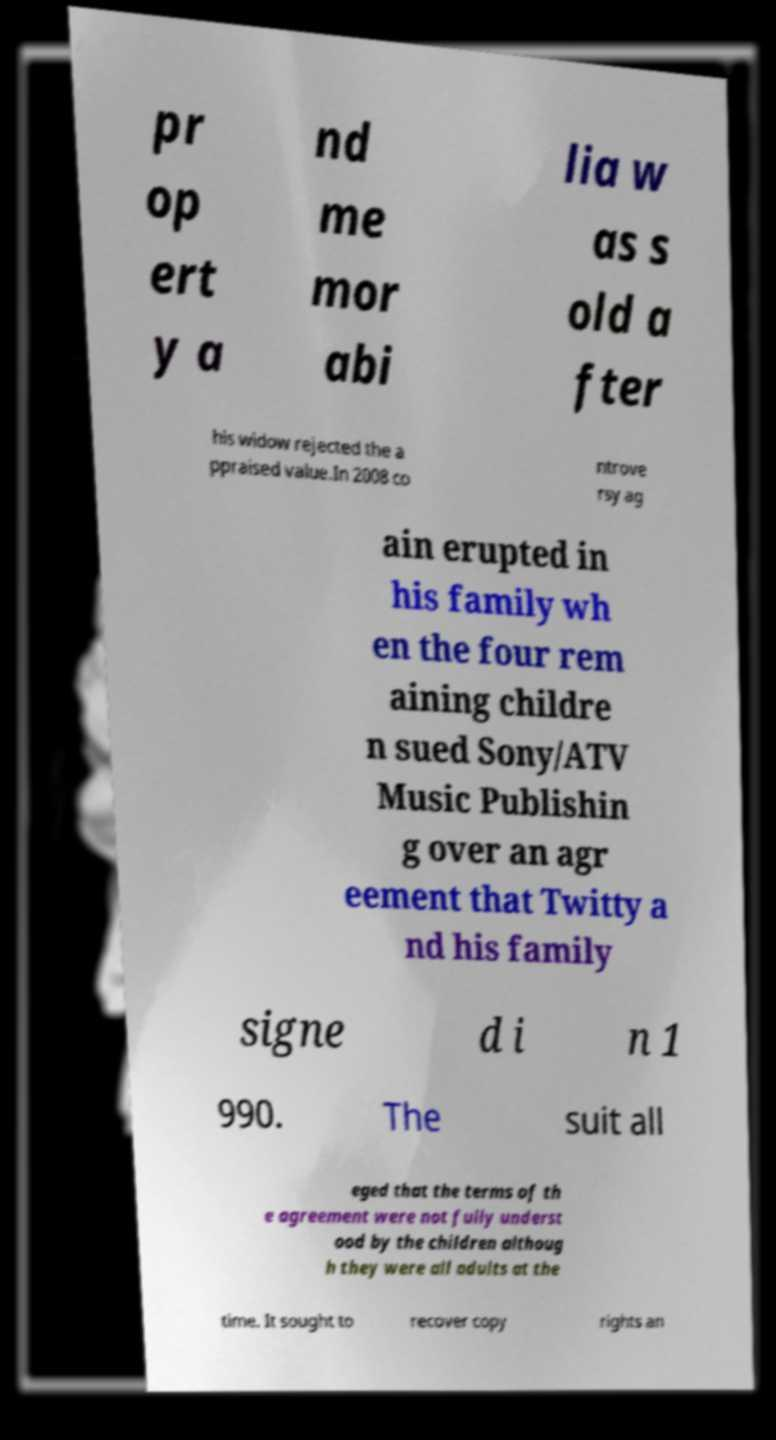Could you extract and type out the text from this image? pr op ert y a nd me mor abi lia w as s old a fter his widow rejected the a ppraised value.In 2008 co ntrove rsy ag ain erupted in his family wh en the four rem aining childre n sued Sony/ATV Music Publishin g over an agr eement that Twitty a nd his family signe d i n 1 990. The suit all eged that the terms of th e agreement were not fully underst ood by the children althoug h they were all adults at the time. It sought to recover copy rights an 